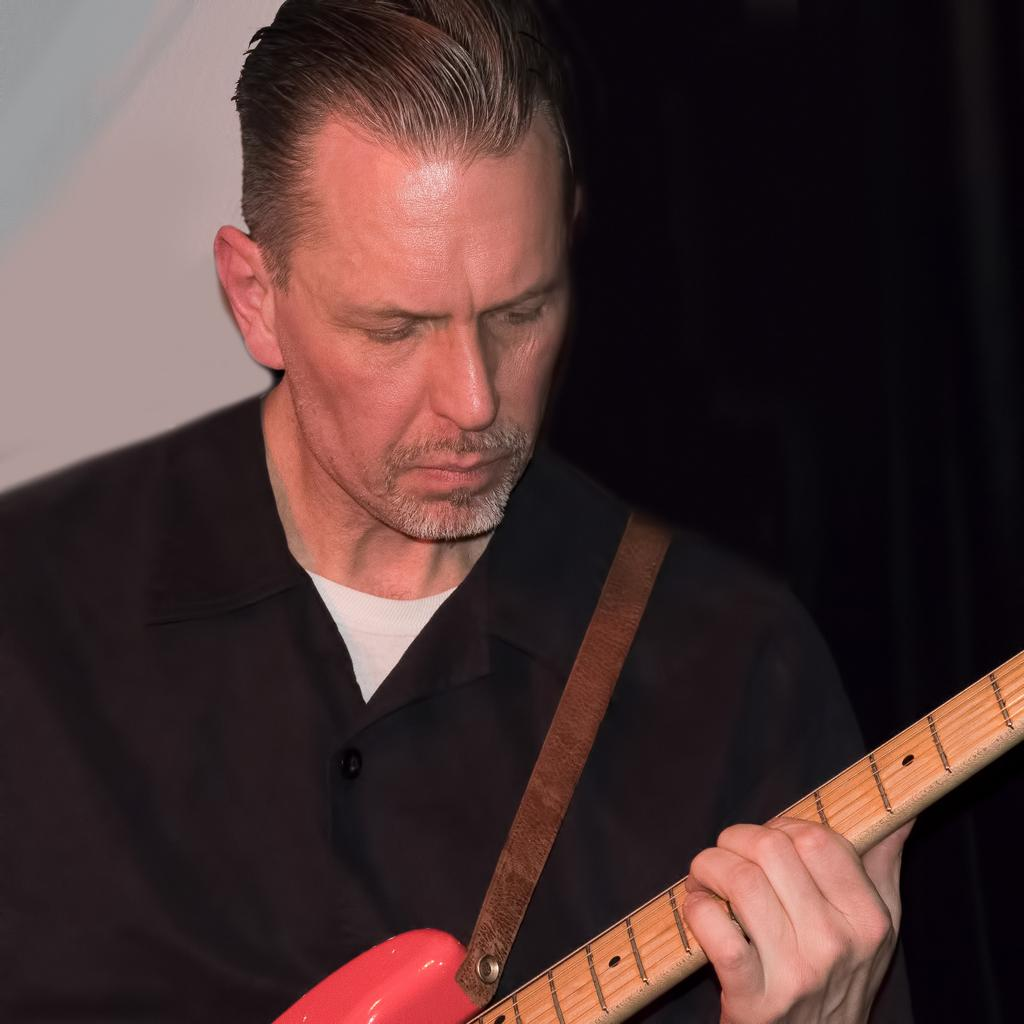Who is present in the image? There is a man in the image. What is the man wearing? The man is wearing a black blazer. What is the man holding in the image? The man is holding a guitar. What can be seen in the background of the image? There is a wall in the background of the image. Is there any dirt visible on the man's shoes in the image? There is no information about the man's shoes in the provided facts, so it cannot be determined if there is any dirt visible on them. 